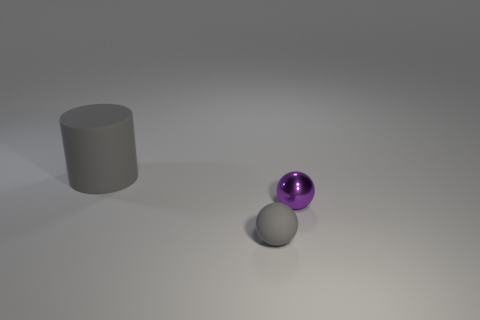Subtract all purple spheres. How many spheres are left? 1 Add 1 gray objects. How many objects exist? 4 Subtract all cylinders. How many objects are left? 2 Subtract 1 cylinders. How many cylinders are left? 0 Add 2 gray balls. How many gray balls exist? 3 Subtract 1 gray balls. How many objects are left? 2 Subtract all brown balls. Subtract all yellow cylinders. How many balls are left? 2 Subtract all blue cylinders. How many gray spheres are left? 1 Subtract all tiny red rubber balls. Subtract all purple spheres. How many objects are left? 2 Add 3 tiny purple balls. How many tiny purple balls are left? 4 